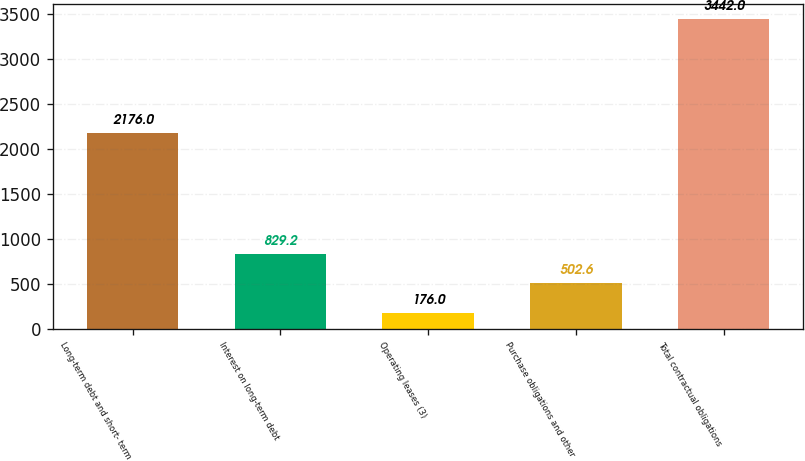Convert chart to OTSL. <chart><loc_0><loc_0><loc_500><loc_500><bar_chart><fcel>Long-term debt and short- term<fcel>Interest on long-term debt<fcel>Operating leases (3)<fcel>Purchase obligations and other<fcel>Total contractual obligations<nl><fcel>2176<fcel>829.2<fcel>176<fcel>502.6<fcel>3442<nl></chart> 